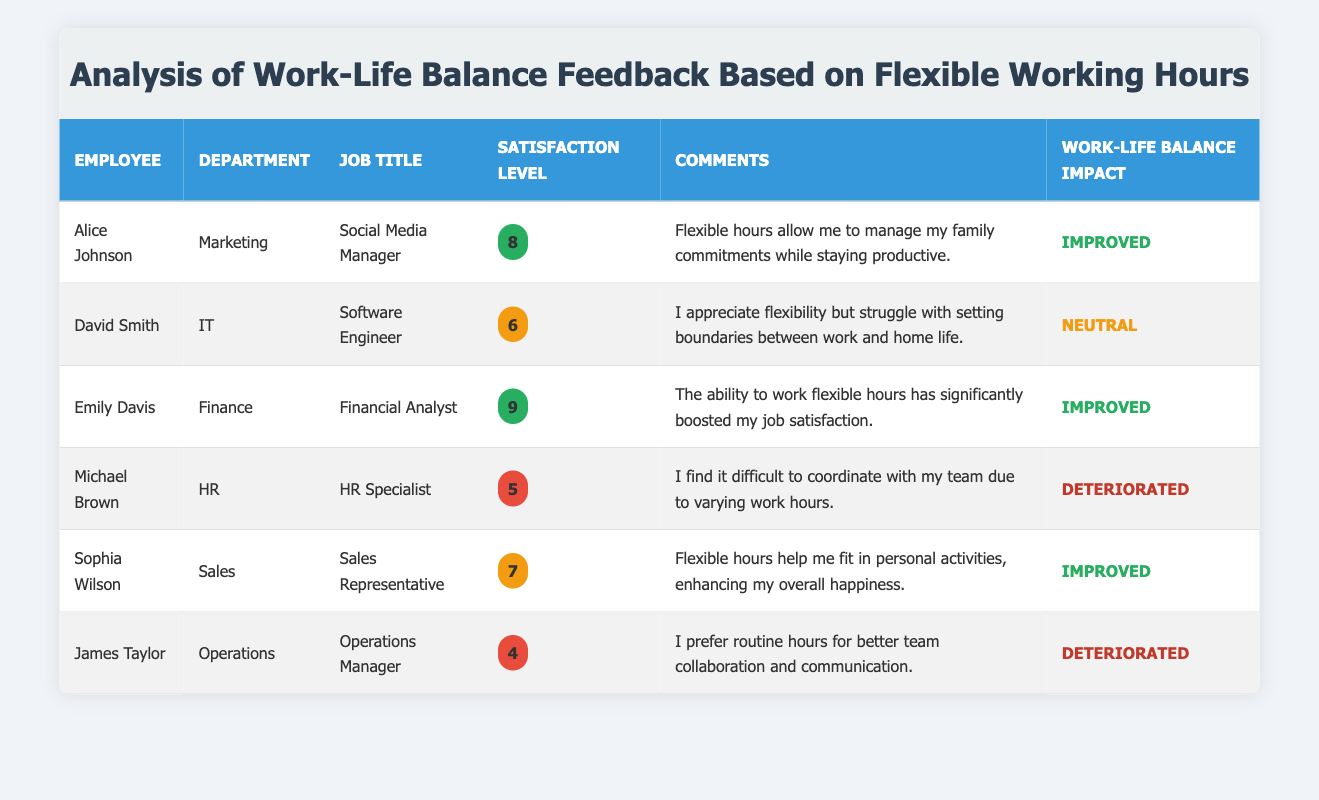What is the satisfaction level of Emily Davis? Emily Davis is listed in the table with a satisfaction level indicated within a colored span. According to the table, her satisfaction level is 9.
Answer: 9 Which employee reported a deterioration in their work-life balance? By looking at the "Work-Life Balance Impact" column, both Michael Brown and James Taylor reported a deterioration in their work-life balance.
Answer: Michael Brown, James Taylor What is the average satisfaction level of employees in the Sales department? The Sales department has one employee, Sophia Wilson, with a satisfaction level of 7. Therefore, the average satisfaction level for the Sales department is simply 7.
Answer: 7 Did any employees express a neutral impact on their work-life balance? In the "Work-Life Balance Impact" column, David Smith is the only employee who reported a neutral impact on his work-life balance.
Answer: Yes How many employees reported an improved work-life balance? Alice Johnson, Emily Davis, and Sophia Wilson all reported an improved work-life balance. Adding this up gives a total of three employees who reported improved work-life balance.
Answer: 3 What is the difference between the highest and lowest satisfaction level among the employees? The highest satisfaction level is 9 (Emily Davis), and the lowest is 4 (James Taylor). The difference is calculated as 9 - 4 = 5.
Answer: 5 How many departments have employees who found their work-life balance deteriorated? The departments with employees reporting a deterioration in work-life balance are HR (Michael Brown) and Operations (James Taylor). This sums up to two different departments indicating issues.
Answer: 2 Who has the highest satisfaction level and what is their comment about flexible hours? Emily Davis, with a satisfaction level of 9, commented that “The ability to work flexible hours has significantly boosted my job satisfaction.”
Answer: Emily Davis; "The ability to work flexible hours has significantly boosted my job satisfaction." Does David Smith believe that flexible working hours positively impact his work-life balance? David Smith described his experience as neutral, indicating a struggle with boundaries between work and home life. Therefore, he does not believe it positively impacts his work-life balance.
Answer: No 